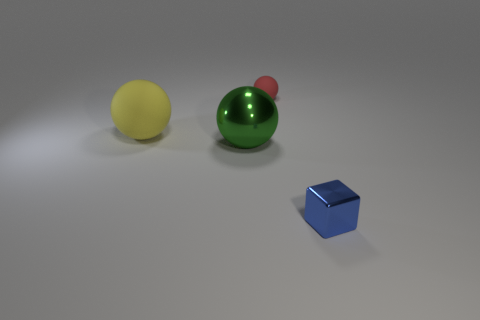Subtract all large balls. How many balls are left? 1 Add 4 large yellow matte spheres. How many objects exist? 8 Subtract all green spheres. How many spheres are left? 2 Subtract all balls. How many objects are left? 1 Subtract 1 cubes. How many cubes are left? 0 Subtract all cyan spheres. Subtract all cyan blocks. How many spheres are left? 3 Subtract all red blocks. How many red spheres are left? 1 Subtract all big green shiny objects. Subtract all blue metal things. How many objects are left? 2 Add 1 yellow matte things. How many yellow matte things are left? 2 Add 3 small brown blocks. How many small brown blocks exist? 3 